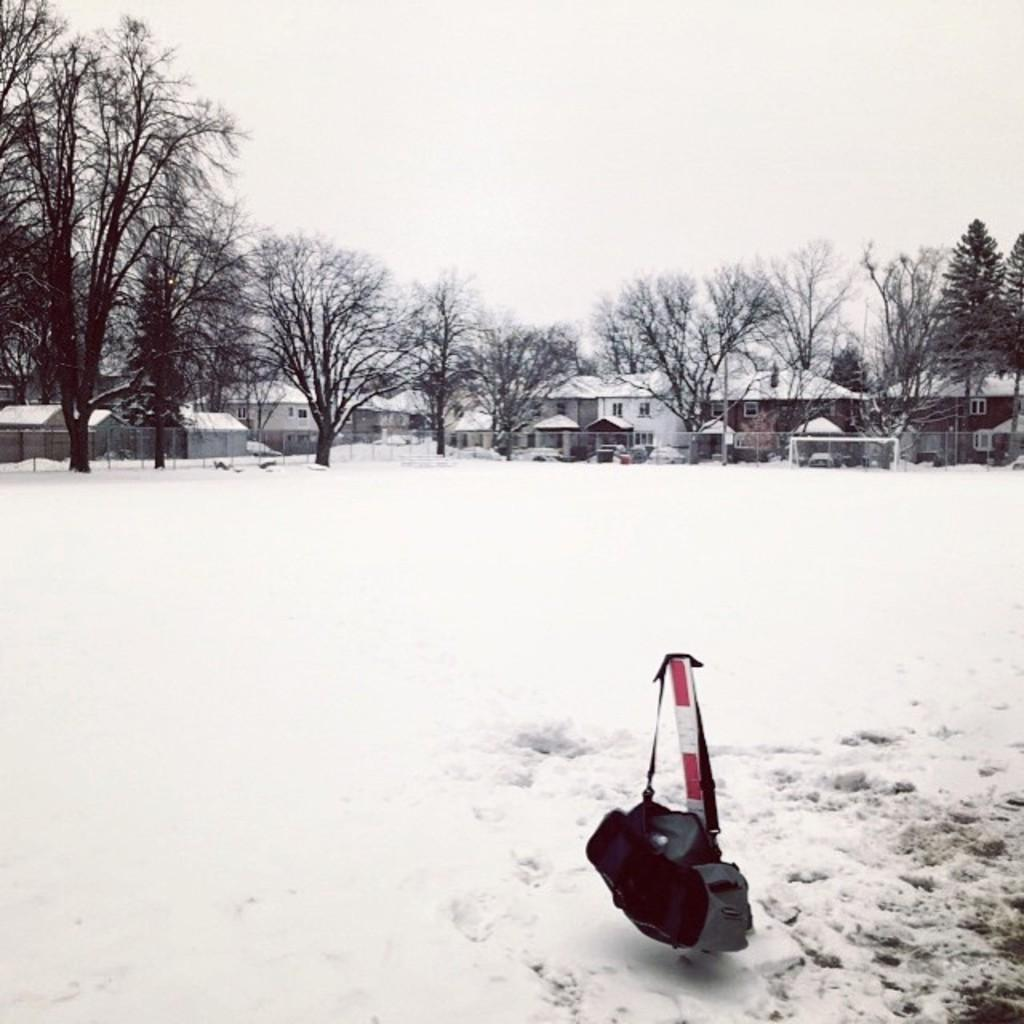What is hanging on the road in the image? There is a bag hanging on the road in the image. What is the condition of the surface in the image? There is snow on the surface in the image. What can be seen in the background of the image? There are trees and buildings in the background of the image, as well as the sky. How many horses are visible in the image? There are no horses present in the image. What type of card is being used to shovel the snow in the image? There is no card or shoveling activity depicted in the image; it simply shows a bag hanging on the road with snow on the surface. 